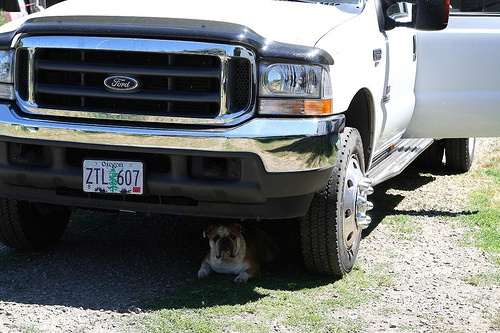Describe the objects in this image and their specific colors. I can see car in black, white, darkgray, and gray tones and dog in black, gray, and darkblue tones in this image. 